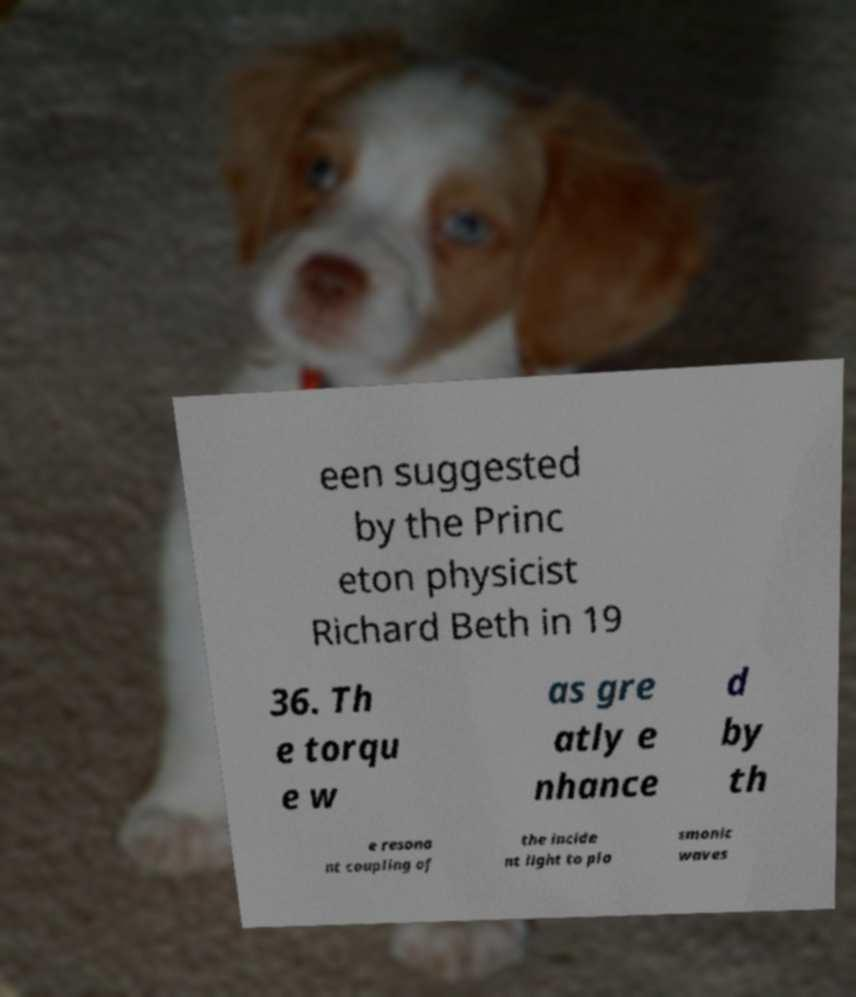Could you assist in decoding the text presented in this image and type it out clearly? een suggested by the Princ eton physicist Richard Beth in 19 36. Th e torqu e w as gre atly e nhance d by th e resona nt coupling of the incide nt light to pla smonic waves 